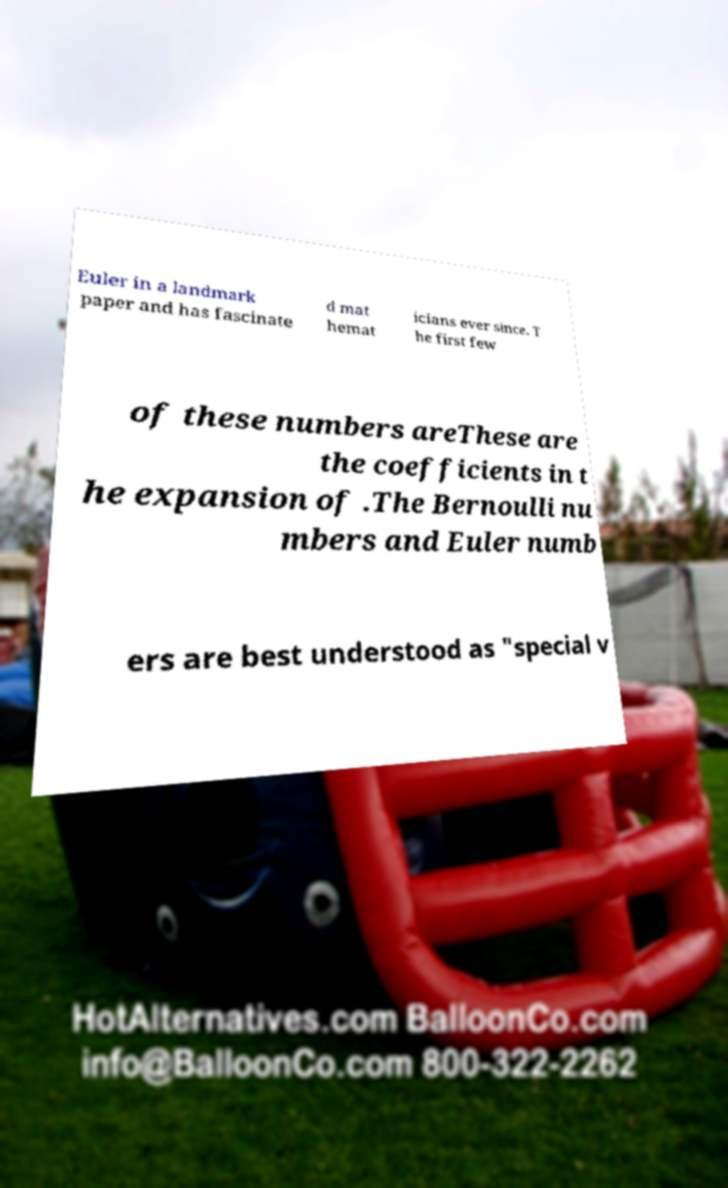What messages or text are displayed in this image? I need them in a readable, typed format. Euler in a landmark paper and has fascinate d mat hemat icians ever since. T he first few of these numbers areThese are the coefficients in t he expansion of .The Bernoulli nu mbers and Euler numb ers are best understood as "special v 